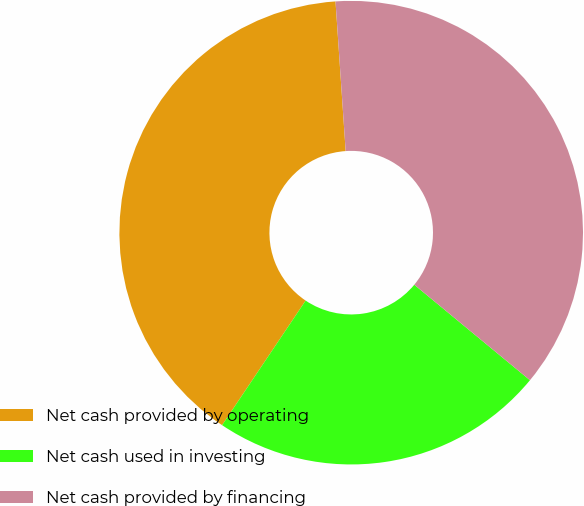<chart> <loc_0><loc_0><loc_500><loc_500><pie_chart><fcel>Net cash provided by operating<fcel>Net cash used in investing<fcel>Net cash provided by financing<nl><fcel>39.52%<fcel>23.42%<fcel>37.06%<nl></chart> 